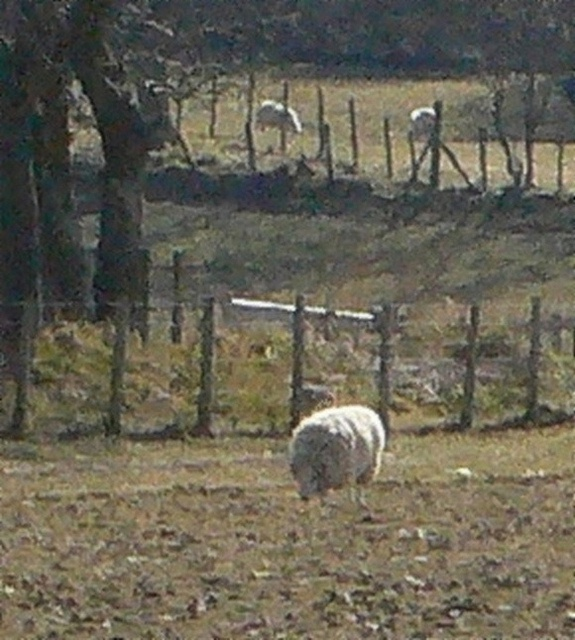Describe the objects in this image and their specific colors. I can see sheep in purple, gray, ivory, and darkgray tones, sheep in purple, gray, darkgray, and lightgray tones, and sheep in purple, gray, lightgray, darkgray, and black tones in this image. 